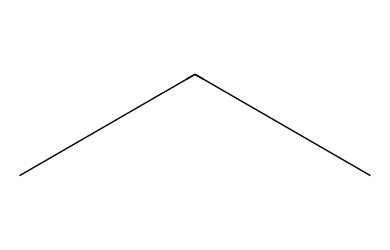What is the main type of polymer represented by this structure? The SMILES representation indicates a hydrocarbon chain made up of saturated carbon atoms, which means it is a saturated polymer commonly known as polyethylene.
Answer: polyethylene How many carbon atoms are present in the structural formula? The SMILES notation "C(C)C" indicates there are three carbon atoms. Since there are two 'C's in parentheses, it indicates branches, but they are all still carbon atoms in the main chain.
Answer: three What type of bonding is found in this polymer structure? The structure shows a series of single bonds between carbon atoms, which is characteristic of saturated hydrocarbons. There are no double or triple bonds present in the given structure.
Answer: single bonds Is this polymer considered low-density or high-density? The structure "C(C)C" suggests a more linear arrangement without branching, which defines it as high-density polyethylene (HDPE). HDPE has a tighter packing of its molecules than low-density polyethylene.
Answer: high-density What is the molecular formula corresponding to this significant structural feature? Based on the structure "C(C)C" which indicates three carbon atoms and the saturation of hydrogen linked to each carbon, the molecular formula can be deduced as C3H6.
Answer: C3H6 How does the lack of branching in its structure affect its properties? The absence of branching in the structure contributes to the density, strength, and rigidity of the material, making it suitable for applications requiring durability.
Answer: increased strength 